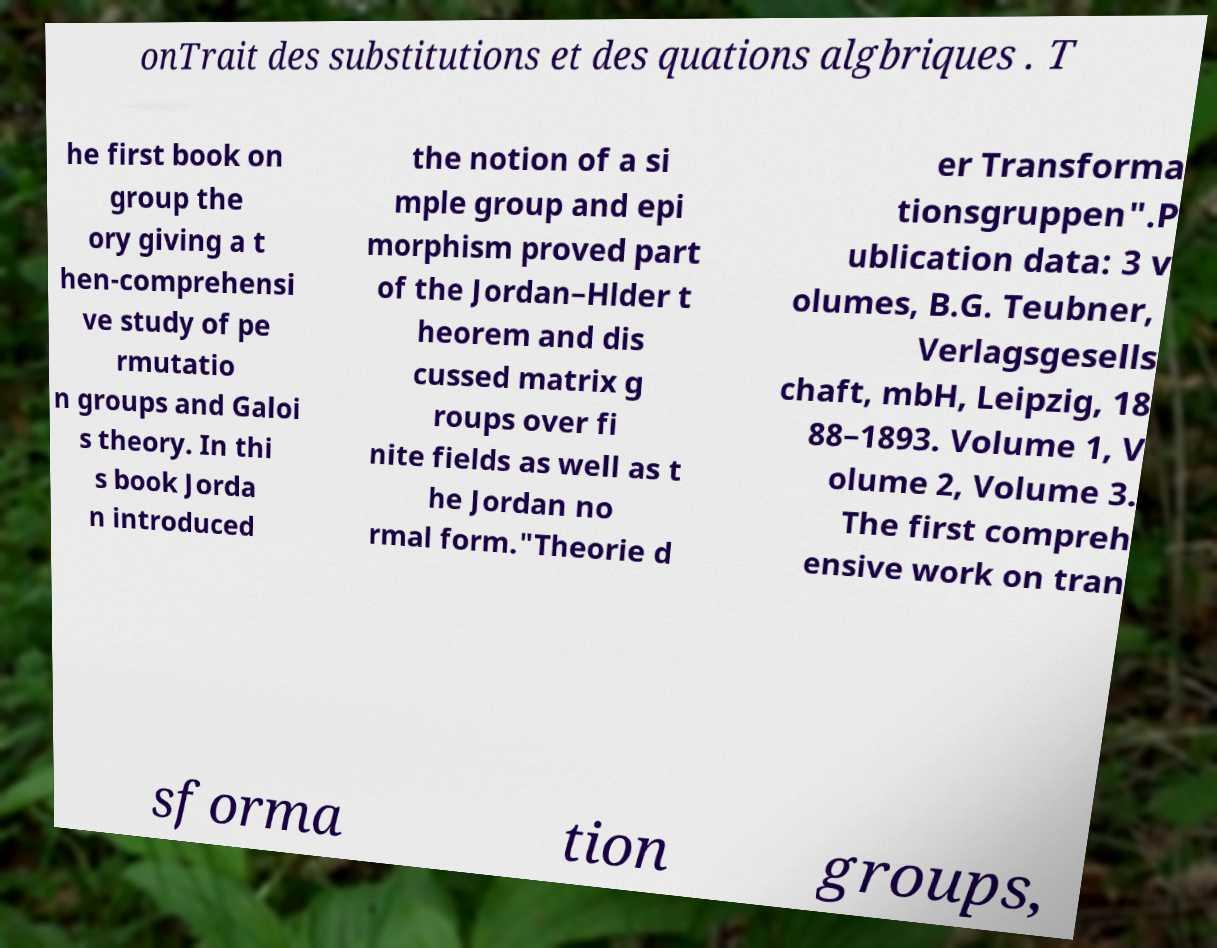Could you assist in decoding the text presented in this image and type it out clearly? onTrait des substitutions et des quations algbriques . T he first book on group the ory giving a t hen-comprehensi ve study of pe rmutatio n groups and Galoi s theory. In thi s book Jorda n introduced the notion of a si mple group and epi morphism proved part of the Jordan–Hlder t heorem and dis cussed matrix g roups over fi nite fields as well as t he Jordan no rmal form."Theorie d er Transforma tionsgruppen".P ublication data: 3 v olumes, B.G. Teubner, Verlagsgesells chaft, mbH, Leipzig, 18 88–1893. Volume 1, V olume 2, Volume 3. The first compreh ensive work on tran sforma tion groups, 